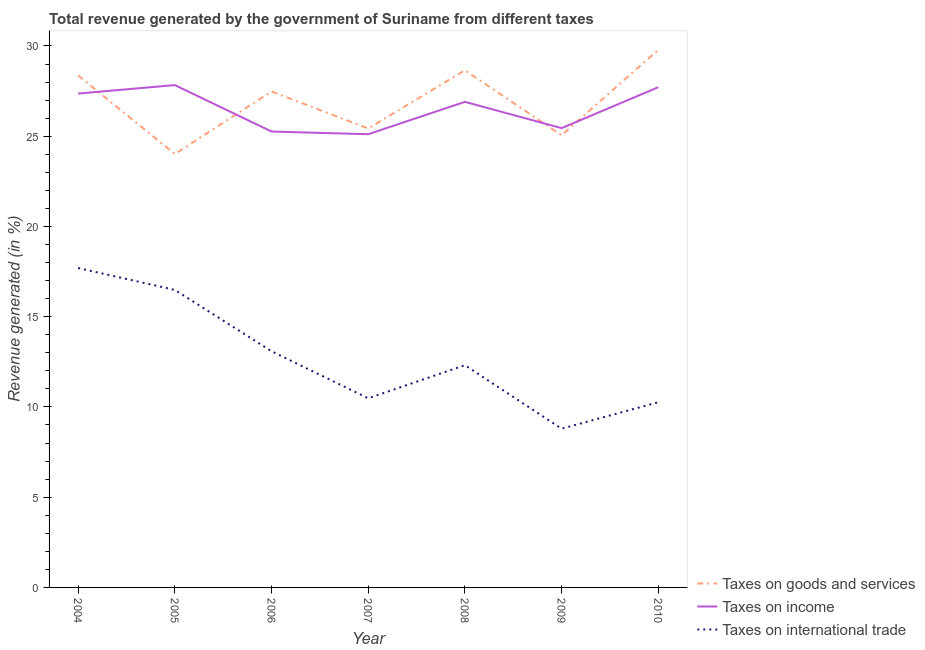Does the line corresponding to percentage of revenue generated by taxes on income intersect with the line corresponding to percentage of revenue generated by tax on international trade?
Ensure brevity in your answer.  No. What is the percentage of revenue generated by taxes on income in 2008?
Give a very brief answer. 26.9. Across all years, what is the maximum percentage of revenue generated by tax on international trade?
Make the answer very short. 17.7. Across all years, what is the minimum percentage of revenue generated by taxes on income?
Your response must be concise. 25.11. In which year was the percentage of revenue generated by tax on international trade minimum?
Offer a very short reply. 2009. What is the total percentage of revenue generated by tax on international trade in the graph?
Give a very brief answer. 89.12. What is the difference between the percentage of revenue generated by tax on international trade in 2004 and that in 2009?
Your response must be concise. 8.9. What is the difference between the percentage of revenue generated by taxes on goods and services in 2008 and the percentage of revenue generated by taxes on income in 2005?
Offer a terse response. 0.82. What is the average percentage of revenue generated by taxes on goods and services per year?
Your response must be concise. 26.97. In the year 2008, what is the difference between the percentage of revenue generated by taxes on income and percentage of revenue generated by tax on international trade?
Your response must be concise. 14.59. In how many years, is the percentage of revenue generated by tax on international trade greater than 26 %?
Provide a short and direct response. 0. What is the ratio of the percentage of revenue generated by taxes on income in 2007 to that in 2009?
Make the answer very short. 0.99. Is the percentage of revenue generated by tax on international trade in 2004 less than that in 2008?
Give a very brief answer. No. What is the difference between the highest and the second highest percentage of revenue generated by tax on international trade?
Your answer should be compact. 1.21. What is the difference between the highest and the lowest percentage of revenue generated by tax on international trade?
Your response must be concise. 8.9. In how many years, is the percentage of revenue generated by tax on international trade greater than the average percentage of revenue generated by tax on international trade taken over all years?
Provide a succinct answer. 3. Is it the case that in every year, the sum of the percentage of revenue generated by taxes on goods and services and percentage of revenue generated by taxes on income is greater than the percentage of revenue generated by tax on international trade?
Provide a succinct answer. Yes. Does the percentage of revenue generated by taxes on income monotonically increase over the years?
Offer a terse response. No. How many years are there in the graph?
Provide a short and direct response. 7. Does the graph contain any zero values?
Offer a very short reply. No. Where does the legend appear in the graph?
Give a very brief answer. Bottom right. How are the legend labels stacked?
Your answer should be very brief. Vertical. What is the title of the graph?
Offer a terse response. Total revenue generated by the government of Suriname from different taxes. What is the label or title of the X-axis?
Offer a terse response. Year. What is the label or title of the Y-axis?
Your answer should be very brief. Revenue generated (in %). What is the Revenue generated (in %) of Taxes on goods and services in 2004?
Make the answer very short. 28.37. What is the Revenue generated (in %) in Taxes on income in 2004?
Your answer should be compact. 27.36. What is the Revenue generated (in %) of Taxes on international trade in 2004?
Keep it short and to the point. 17.7. What is the Revenue generated (in %) of Taxes on goods and services in 2005?
Provide a succinct answer. 24.01. What is the Revenue generated (in %) in Taxes on income in 2005?
Give a very brief answer. 27.83. What is the Revenue generated (in %) of Taxes on international trade in 2005?
Offer a terse response. 16.48. What is the Revenue generated (in %) of Taxes on goods and services in 2006?
Provide a succinct answer. 27.48. What is the Revenue generated (in %) of Taxes on income in 2006?
Your response must be concise. 25.26. What is the Revenue generated (in %) in Taxes on international trade in 2006?
Ensure brevity in your answer.  13.09. What is the Revenue generated (in %) in Taxes on goods and services in 2007?
Your response must be concise. 25.43. What is the Revenue generated (in %) in Taxes on income in 2007?
Offer a very short reply. 25.11. What is the Revenue generated (in %) of Taxes on international trade in 2007?
Provide a short and direct response. 10.48. What is the Revenue generated (in %) in Taxes on goods and services in 2008?
Give a very brief answer. 28.65. What is the Revenue generated (in %) in Taxes on income in 2008?
Your answer should be very brief. 26.9. What is the Revenue generated (in %) in Taxes on international trade in 2008?
Keep it short and to the point. 12.31. What is the Revenue generated (in %) of Taxes on goods and services in 2009?
Your answer should be very brief. 25.05. What is the Revenue generated (in %) in Taxes on income in 2009?
Offer a terse response. 25.45. What is the Revenue generated (in %) of Taxes on international trade in 2009?
Provide a short and direct response. 8.79. What is the Revenue generated (in %) of Taxes on goods and services in 2010?
Provide a succinct answer. 29.79. What is the Revenue generated (in %) in Taxes on income in 2010?
Give a very brief answer. 27.72. What is the Revenue generated (in %) of Taxes on international trade in 2010?
Offer a terse response. 10.26. Across all years, what is the maximum Revenue generated (in %) in Taxes on goods and services?
Offer a very short reply. 29.79. Across all years, what is the maximum Revenue generated (in %) in Taxes on income?
Make the answer very short. 27.83. Across all years, what is the maximum Revenue generated (in %) of Taxes on international trade?
Keep it short and to the point. 17.7. Across all years, what is the minimum Revenue generated (in %) in Taxes on goods and services?
Make the answer very short. 24.01. Across all years, what is the minimum Revenue generated (in %) in Taxes on income?
Offer a terse response. 25.11. Across all years, what is the minimum Revenue generated (in %) of Taxes on international trade?
Your response must be concise. 8.79. What is the total Revenue generated (in %) of Taxes on goods and services in the graph?
Your answer should be compact. 188.78. What is the total Revenue generated (in %) in Taxes on income in the graph?
Offer a very short reply. 185.63. What is the total Revenue generated (in %) of Taxes on international trade in the graph?
Provide a short and direct response. 89.12. What is the difference between the Revenue generated (in %) of Taxes on goods and services in 2004 and that in 2005?
Provide a short and direct response. 4.36. What is the difference between the Revenue generated (in %) of Taxes on income in 2004 and that in 2005?
Your answer should be very brief. -0.47. What is the difference between the Revenue generated (in %) of Taxes on international trade in 2004 and that in 2005?
Provide a short and direct response. 1.21. What is the difference between the Revenue generated (in %) of Taxes on goods and services in 2004 and that in 2006?
Provide a short and direct response. 0.89. What is the difference between the Revenue generated (in %) in Taxes on income in 2004 and that in 2006?
Provide a succinct answer. 2.1. What is the difference between the Revenue generated (in %) in Taxes on international trade in 2004 and that in 2006?
Keep it short and to the point. 4.61. What is the difference between the Revenue generated (in %) in Taxes on goods and services in 2004 and that in 2007?
Your answer should be compact. 2.94. What is the difference between the Revenue generated (in %) in Taxes on income in 2004 and that in 2007?
Offer a terse response. 2.25. What is the difference between the Revenue generated (in %) of Taxes on international trade in 2004 and that in 2007?
Your answer should be compact. 7.22. What is the difference between the Revenue generated (in %) of Taxes on goods and services in 2004 and that in 2008?
Make the answer very short. -0.28. What is the difference between the Revenue generated (in %) in Taxes on income in 2004 and that in 2008?
Keep it short and to the point. 0.46. What is the difference between the Revenue generated (in %) of Taxes on international trade in 2004 and that in 2008?
Give a very brief answer. 5.38. What is the difference between the Revenue generated (in %) of Taxes on goods and services in 2004 and that in 2009?
Your response must be concise. 3.32. What is the difference between the Revenue generated (in %) of Taxes on income in 2004 and that in 2009?
Give a very brief answer. 1.92. What is the difference between the Revenue generated (in %) of Taxes on international trade in 2004 and that in 2009?
Keep it short and to the point. 8.9. What is the difference between the Revenue generated (in %) in Taxes on goods and services in 2004 and that in 2010?
Make the answer very short. -1.42. What is the difference between the Revenue generated (in %) in Taxes on income in 2004 and that in 2010?
Your response must be concise. -0.35. What is the difference between the Revenue generated (in %) of Taxes on international trade in 2004 and that in 2010?
Your answer should be very brief. 7.44. What is the difference between the Revenue generated (in %) of Taxes on goods and services in 2005 and that in 2006?
Your answer should be compact. -3.47. What is the difference between the Revenue generated (in %) in Taxes on income in 2005 and that in 2006?
Keep it short and to the point. 2.57. What is the difference between the Revenue generated (in %) of Taxes on international trade in 2005 and that in 2006?
Offer a terse response. 3.4. What is the difference between the Revenue generated (in %) of Taxes on goods and services in 2005 and that in 2007?
Provide a short and direct response. -1.42. What is the difference between the Revenue generated (in %) in Taxes on income in 2005 and that in 2007?
Offer a terse response. 2.72. What is the difference between the Revenue generated (in %) of Taxes on international trade in 2005 and that in 2007?
Make the answer very short. 6. What is the difference between the Revenue generated (in %) in Taxes on goods and services in 2005 and that in 2008?
Provide a short and direct response. -4.64. What is the difference between the Revenue generated (in %) of Taxes on income in 2005 and that in 2008?
Ensure brevity in your answer.  0.93. What is the difference between the Revenue generated (in %) in Taxes on international trade in 2005 and that in 2008?
Your answer should be very brief. 4.17. What is the difference between the Revenue generated (in %) of Taxes on goods and services in 2005 and that in 2009?
Offer a very short reply. -1.04. What is the difference between the Revenue generated (in %) in Taxes on income in 2005 and that in 2009?
Make the answer very short. 2.38. What is the difference between the Revenue generated (in %) in Taxes on international trade in 2005 and that in 2009?
Provide a succinct answer. 7.69. What is the difference between the Revenue generated (in %) of Taxes on goods and services in 2005 and that in 2010?
Ensure brevity in your answer.  -5.78. What is the difference between the Revenue generated (in %) in Taxes on income in 2005 and that in 2010?
Make the answer very short. 0.12. What is the difference between the Revenue generated (in %) of Taxes on international trade in 2005 and that in 2010?
Keep it short and to the point. 6.22. What is the difference between the Revenue generated (in %) in Taxes on goods and services in 2006 and that in 2007?
Offer a terse response. 2.05. What is the difference between the Revenue generated (in %) of Taxes on income in 2006 and that in 2007?
Provide a succinct answer. 0.15. What is the difference between the Revenue generated (in %) of Taxes on international trade in 2006 and that in 2007?
Your response must be concise. 2.61. What is the difference between the Revenue generated (in %) of Taxes on goods and services in 2006 and that in 2008?
Keep it short and to the point. -1.17. What is the difference between the Revenue generated (in %) of Taxes on income in 2006 and that in 2008?
Offer a very short reply. -1.64. What is the difference between the Revenue generated (in %) in Taxes on international trade in 2006 and that in 2008?
Keep it short and to the point. 0.77. What is the difference between the Revenue generated (in %) in Taxes on goods and services in 2006 and that in 2009?
Provide a succinct answer. 2.43. What is the difference between the Revenue generated (in %) of Taxes on income in 2006 and that in 2009?
Provide a succinct answer. -0.19. What is the difference between the Revenue generated (in %) of Taxes on international trade in 2006 and that in 2009?
Offer a very short reply. 4.29. What is the difference between the Revenue generated (in %) of Taxes on goods and services in 2006 and that in 2010?
Make the answer very short. -2.31. What is the difference between the Revenue generated (in %) in Taxes on income in 2006 and that in 2010?
Your answer should be very brief. -2.46. What is the difference between the Revenue generated (in %) in Taxes on international trade in 2006 and that in 2010?
Ensure brevity in your answer.  2.83. What is the difference between the Revenue generated (in %) in Taxes on goods and services in 2007 and that in 2008?
Ensure brevity in your answer.  -3.22. What is the difference between the Revenue generated (in %) in Taxes on income in 2007 and that in 2008?
Ensure brevity in your answer.  -1.79. What is the difference between the Revenue generated (in %) of Taxes on international trade in 2007 and that in 2008?
Offer a very short reply. -1.83. What is the difference between the Revenue generated (in %) in Taxes on goods and services in 2007 and that in 2009?
Give a very brief answer. 0.38. What is the difference between the Revenue generated (in %) in Taxes on income in 2007 and that in 2009?
Provide a succinct answer. -0.34. What is the difference between the Revenue generated (in %) in Taxes on international trade in 2007 and that in 2009?
Ensure brevity in your answer.  1.69. What is the difference between the Revenue generated (in %) in Taxes on goods and services in 2007 and that in 2010?
Offer a very short reply. -4.36. What is the difference between the Revenue generated (in %) of Taxes on income in 2007 and that in 2010?
Provide a short and direct response. -2.6. What is the difference between the Revenue generated (in %) in Taxes on international trade in 2007 and that in 2010?
Offer a terse response. 0.22. What is the difference between the Revenue generated (in %) in Taxes on goods and services in 2008 and that in 2009?
Your response must be concise. 3.6. What is the difference between the Revenue generated (in %) of Taxes on income in 2008 and that in 2009?
Ensure brevity in your answer.  1.46. What is the difference between the Revenue generated (in %) of Taxes on international trade in 2008 and that in 2009?
Provide a succinct answer. 3.52. What is the difference between the Revenue generated (in %) of Taxes on goods and services in 2008 and that in 2010?
Keep it short and to the point. -1.14. What is the difference between the Revenue generated (in %) in Taxes on income in 2008 and that in 2010?
Your answer should be compact. -0.81. What is the difference between the Revenue generated (in %) of Taxes on international trade in 2008 and that in 2010?
Your response must be concise. 2.05. What is the difference between the Revenue generated (in %) in Taxes on goods and services in 2009 and that in 2010?
Make the answer very short. -4.74. What is the difference between the Revenue generated (in %) in Taxes on income in 2009 and that in 2010?
Offer a terse response. -2.27. What is the difference between the Revenue generated (in %) in Taxes on international trade in 2009 and that in 2010?
Ensure brevity in your answer.  -1.47. What is the difference between the Revenue generated (in %) of Taxes on goods and services in 2004 and the Revenue generated (in %) of Taxes on income in 2005?
Make the answer very short. 0.54. What is the difference between the Revenue generated (in %) of Taxes on goods and services in 2004 and the Revenue generated (in %) of Taxes on international trade in 2005?
Make the answer very short. 11.88. What is the difference between the Revenue generated (in %) in Taxes on income in 2004 and the Revenue generated (in %) in Taxes on international trade in 2005?
Provide a succinct answer. 10.88. What is the difference between the Revenue generated (in %) in Taxes on goods and services in 2004 and the Revenue generated (in %) in Taxes on income in 2006?
Your answer should be very brief. 3.11. What is the difference between the Revenue generated (in %) in Taxes on goods and services in 2004 and the Revenue generated (in %) in Taxes on international trade in 2006?
Make the answer very short. 15.28. What is the difference between the Revenue generated (in %) of Taxes on income in 2004 and the Revenue generated (in %) of Taxes on international trade in 2006?
Your answer should be very brief. 14.28. What is the difference between the Revenue generated (in %) in Taxes on goods and services in 2004 and the Revenue generated (in %) in Taxes on income in 2007?
Keep it short and to the point. 3.26. What is the difference between the Revenue generated (in %) of Taxes on goods and services in 2004 and the Revenue generated (in %) of Taxes on international trade in 2007?
Your answer should be very brief. 17.89. What is the difference between the Revenue generated (in %) of Taxes on income in 2004 and the Revenue generated (in %) of Taxes on international trade in 2007?
Offer a terse response. 16.88. What is the difference between the Revenue generated (in %) of Taxes on goods and services in 2004 and the Revenue generated (in %) of Taxes on income in 2008?
Provide a short and direct response. 1.46. What is the difference between the Revenue generated (in %) of Taxes on goods and services in 2004 and the Revenue generated (in %) of Taxes on international trade in 2008?
Offer a terse response. 16.05. What is the difference between the Revenue generated (in %) in Taxes on income in 2004 and the Revenue generated (in %) in Taxes on international trade in 2008?
Give a very brief answer. 15.05. What is the difference between the Revenue generated (in %) in Taxes on goods and services in 2004 and the Revenue generated (in %) in Taxes on income in 2009?
Ensure brevity in your answer.  2.92. What is the difference between the Revenue generated (in %) in Taxes on goods and services in 2004 and the Revenue generated (in %) in Taxes on international trade in 2009?
Your response must be concise. 19.57. What is the difference between the Revenue generated (in %) in Taxes on income in 2004 and the Revenue generated (in %) in Taxes on international trade in 2009?
Keep it short and to the point. 18.57. What is the difference between the Revenue generated (in %) in Taxes on goods and services in 2004 and the Revenue generated (in %) in Taxes on income in 2010?
Give a very brief answer. 0.65. What is the difference between the Revenue generated (in %) in Taxes on goods and services in 2004 and the Revenue generated (in %) in Taxes on international trade in 2010?
Provide a short and direct response. 18.11. What is the difference between the Revenue generated (in %) in Taxes on income in 2004 and the Revenue generated (in %) in Taxes on international trade in 2010?
Your answer should be very brief. 17.1. What is the difference between the Revenue generated (in %) of Taxes on goods and services in 2005 and the Revenue generated (in %) of Taxes on income in 2006?
Your answer should be very brief. -1.25. What is the difference between the Revenue generated (in %) in Taxes on goods and services in 2005 and the Revenue generated (in %) in Taxes on international trade in 2006?
Provide a succinct answer. 10.93. What is the difference between the Revenue generated (in %) in Taxes on income in 2005 and the Revenue generated (in %) in Taxes on international trade in 2006?
Ensure brevity in your answer.  14.75. What is the difference between the Revenue generated (in %) in Taxes on goods and services in 2005 and the Revenue generated (in %) in Taxes on income in 2007?
Offer a very short reply. -1.1. What is the difference between the Revenue generated (in %) in Taxes on goods and services in 2005 and the Revenue generated (in %) in Taxes on international trade in 2007?
Give a very brief answer. 13.53. What is the difference between the Revenue generated (in %) in Taxes on income in 2005 and the Revenue generated (in %) in Taxes on international trade in 2007?
Keep it short and to the point. 17.35. What is the difference between the Revenue generated (in %) of Taxes on goods and services in 2005 and the Revenue generated (in %) of Taxes on income in 2008?
Give a very brief answer. -2.89. What is the difference between the Revenue generated (in %) in Taxes on goods and services in 2005 and the Revenue generated (in %) in Taxes on international trade in 2008?
Your response must be concise. 11.7. What is the difference between the Revenue generated (in %) of Taxes on income in 2005 and the Revenue generated (in %) of Taxes on international trade in 2008?
Make the answer very short. 15.52. What is the difference between the Revenue generated (in %) in Taxes on goods and services in 2005 and the Revenue generated (in %) in Taxes on income in 2009?
Ensure brevity in your answer.  -1.44. What is the difference between the Revenue generated (in %) in Taxes on goods and services in 2005 and the Revenue generated (in %) in Taxes on international trade in 2009?
Provide a short and direct response. 15.22. What is the difference between the Revenue generated (in %) in Taxes on income in 2005 and the Revenue generated (in %) in Taxes on international trade in 2009?
Keep it short and to the point. 19.04. What is the difference between the Revenue generated (in %) in Taxes on goods and services in 2005 and the Revenue generated (in %) in Taxes on income in 2010?
Offer a very short reply. -3.7. What is the difference between the Revenue generated (in %) in Taxes on goods and services in 2005 and the Revenue generated (in %) in Taxes on international trade in 2010?
Give a very brief answer. 13.75. What is the difference between the Revenue generated (in %) of Taxes on income in 2005 and the Revenue generated (in %) of Taxes on international trade in 2010?
Offer a very short reply. 17.57. What is the difference between the Revenue generated (in %) in Taxes on goods and services in 2006 and the Revenue generated (in %) in Taxes on income in 2007?
Provide a short and direct response. 2.37. What is the difference between the Revenue generated (in %) of Taxes on goods and services in 2006 and the Revenue generated (in %) of Taxes on international trade in 2007?
Keep it short and to the point. 17. What is the difference between the Revenue generated (in %) in Taxes on income in 2006 and the Revenue generated (in %) in Taxes on international trade in 2007?
Make the answer very short. 14.78. What is the difference between the Revenue generated (in %) in Taxes on goods and services in 2006 and the Revenue generated (in %) in Taxes on income in 2008?
Provide a short and direct response. 0.58. What is the difference between the Revenue generated (in %) in Taxes on goods and services in 2006 and the Revenue generated (in %) in Taxes on international trade in 2008?
Your answer should be very brief. 15.17. What is the difference between the Revenue generated (in %) of Taxes on income in 2006 and the Revenue generated (in %) of Taxes on international trade in 2008?
Make the answer very short. 12.95. What is the difference between the Revenue generated (in %) in Taxes on goods and services in 2006 and the Revenue generated (in %) in Taxes on income in 2009?
Offer a very short reply. 2.03. What is the difference between the Revenue generated (in %) in Taxes on goods and services in 2006 and the Revenue generated (in %) in Taxes on international trade in 2009?
Your response must be concise. 18.69. What is the difference between the Revenue generated (in %) in Taxes on income in 2006 and the Revenue generated (in %) in Taxes on international trade in 2009?
Give a very brief answer. 16.46. What is the difference between the Revenue generated (in %) of Taxes on goods and services in 2006 and the Revenue generated (in %) of Taxes on income in 2010?
Provide a succinct answer. -0.24. What is the difference between the Revenue generated (in %) of Taxes on goods and services in 2006 and the Revenue generated (in %) of Taxes on international trade in 2010?
Your response must be concise. 17.22. What is the difference between the Revenue generated (in %) of Taxes on income in 2006 and the Revenue generated (in %) of Taxes on international trade in 2010?
Provide a succinct answer. 15. What is the difference between the Revenue generated (in %) in Taxes on goods and services in 2007 and the Revenue generated (in %) in Taxes on income in 2008?
Your answer should be compact. -1.48. What is the difference between the Revenue generated (in %) in Taxes on goods and services in 2007 and the Revenue generated (in %) in Taxes on international trade in 2008?
Provide a short and direct response. 13.11. What is the difference between the Revenue generated (in %) of Taxes on income in 2007 and the Revenue generated (in %) of Taxes on international trade in 2008?
Your response must be concise. 12.8. What is the difference between the Revenue generated (in %) of Taxes on goods and services in 2007 and the Revenue generated (in %) of Taxes on income in 2009?
Offer a terse response. -0.02. What is the difference between the Revenue generated (in %) in Taxes on goods and services in 2007 and the Revenue generated (in %) in Taxes on international trade in 2009?
Provide a short and direct response. 16.63. What is the difference between the Revenue generated (in %) of Taxes on income in 2007 and the Revenue generated (in %) of Taxes on international trade in 2009?
Give a very brief answer. 16.32. What is the difference between the Revenue generated (in %) in Taxes on goods and services in 2007 and the Revenue generated (in %) in Taxes on income in 2010?
Your answer should be very brief. -2.29. What is the difference between the Revenue generated (in %) in Taxes on goods and services in 2007 and the Revenue generated (in %) in Taxes on international trade in 2010?
Your response must be concise. 15.17. What is the difference between the Revenue generated (in %) in Taxes on income in 2007 and the Revenue generated (in %) in Taxes on international trade in 2010?
Provide a succinct answer. 14.85. What is the difference between the Revenue generated (in %) of Taxes on goods and services in 2008 and the Revenue generated (in %) of Taxes on income in 2009?
Your answer should be compact. 3.2. What is the difference between the Revenue generated (in %) of Taxes on goods and services in 2008 and the Revenue generated (in %) of Taxes on international trade in 2009?
Provide a short and direct response. 19.86. What is the difference between the Revenue generated (in %) of Taxes on income in 2008 and the Revenue generated (in %) of Taxes on international trade in 2009?
Make the answer very short. 18.11. What is the difference between the Revenue generated (in %) of Taxes on goods and services in 2008 and the Revenue generated (in %) of Taxes on income in 2010?
Your answer should be compact. 0.94. What is the difference between the Revenue generated (in %) in Taxes on goods and services in 2008 and the Revenue generated (in %) in Taxes on international trade in 2010?
Ensure brevity in your answer.  18.39. What is the difference between the Revenue generated (in %) in Taxes on income in 2008 and the Revenue generated (in %) in Taxes on international trade in 2010?
Offer a terse response. 16.64. What is the difference between the Revenue generated (in %) in Taxes on goods and services in 2009 and the Revenue generated (in %) in Taxes on income in 2010?
Offer a terse response. -2.66. What is the difference between the Revenue generated (in %) in Taxes on goods and services in 2009 and the Revenue generated (in %) in Taxes on international trade in 2010?
Offer a very short reply. 14.79. What is the difference between the Revenue generated (in %) in Taxes on income in 2009 and the Revenue generated (in %) in Taxes on international trade in 2010?
Provide a short and direct response. 15.19. What is the average Revenue generated (in %) of Taxes on goods and services per year?
Your answer should be compact. 26.97. What is the average Revenue generated (in %) of Taxes on income per year?
Give a very brief answer. 26.52. What is the average Revenue generated (in %) of Taxes on international trade per year?
Provide a short and direct response. 12.73. In the year 2004, what is the difference between the Revenue generated (in %) in Taxes on goods and services and Revenue generated (in %) in Taxes on income?
Provide a succinct answer. 1.01. In the year 2004, what is the difference between the Revenue generated (in %) in Taxes on goods and services and Revenue generated (in %) in Taxes on international trade?
Keep it short and to the point. 10.67. In the year 2004, what is the difference between the Revenue generated (in %) of Taxes on income and Revenue generated (in %) of Taxes on international trade?
Make the answer very short. 9.67. In the year 2005, what is the difference between the Revenue generated (in %) in Taxes on goods and services and Revenue generated (in %) in Taxes on income?
Your answer should be compact. -3.82. In the year 2005, what is the difference between the Revenue generated (in %) in Taxes on goods and services and Revenue generated (in %) in Taxes on international trade?
Your answer should be compact. 7.53. In the year 2005, what is the difference between the Revenue generated (in %) in Taxes on income and Revenue generated (in %) in Taxes on international trade?
Provide a short and direct response. 11.35. In the year 2006, what is the difference between the Revenue generated (in %) in Taxes on goods and services and Revenue generated (in %) in Taxes on income?
Your answer should be compact. 2.22. In the year 2006, what is the difference between the Revenue generated (in %) of Taxes on goods and services and Revenue generated (in %) of Taxes on international trade?
Offer a terse response. 14.39. In the year 2006, what is the difference between the Revenue generated (in %) of Taxes on income and Revenue generated (in %) of Taxes on international trade?
Provide a short and direct response. 12.17. In the year 2007, what is the difference between the Revenue generated (in %) of Taxes on goods and services and Revenue generated (in %) of Taxes on income?
Give a very brief answer. 0.32. In the year 2007, what is the difference between the Revenue generated (in %) in Taxes on goods and services and Revenue generated (in %) in Taxes on international trade?
Make the answer very short. 14.95. In the year 2007, what is the difference between the Revenue generated (in %) in Taxes on income and Revenue generated (in %) in Taxes on international trade?
Provide a succinct answer. 14.63. In the year 2008, what is the difference between the Revenue generated (in %) in Taxes on goods and services and Revenue generated (in %) in Taxes on income?
Provide a short and direct response. 1.75. In the year 2008, what is the difference between the Revenue generated (in %) in Taxes on goods and services and Revenue generated (in %) in Taxes on international trade?
Ensure brevity in your answer.  16.34. In the year 2008, what is the difference between the Revenue generated (in %) in Taxes on income and Revenue generated (in %) in Taxes on international trade?
Keep it short and to the point. 14.59. In the year 2009, what is the difference between the Revenue generated (in %) in Taxes on goods and services and Revenue generated (in %) in Taxes on income?
Keep it short and to the point. -0.4. In the year 2009, what is the difference between the Revenue generated (in %) of Taxes on goods and services and Revenue generated (in %) of Taxes on international trade?
Ensure brevity in your answer.  16.26. In the year 2009, what is the difference between the Revenue generated (in %) of Taxes on income and Revenue generated (in %) of Taxes on international trade?
Make the answer very short. 16.65. In the year 2010, what is the difference between the Revenue generated (in %) in Taxes on goods and services and Revenue generated (in %) in Taxes on income?
Your response must be concise. 2.07. In the year 2010, what is the difference between the Revenue generated (in %) in Taxes on goods and services and Revenue generated (in %) in Taxes on international trade?
Make the answer very short. 19.53. In the year 2010, what is the difference between the Revenue generated (in %) in Taxes on income and Revenue generated (in %) in Taxes on international trade?
Offer a very short reply. 17.46. What is the ratio of the Revenue generated (in %) in Taxes on goods and services in 2004 to that in 2005?
Make the answer very short. 1.18. What is the ratio of the Revenue generated (in %) of Taxes on income in 2004 to that in 2005?
Offer a very short reply. 0.98. What is the ratio of the Revenue generated (in %) in Taxes on international trade in 2004 to that in 2005?
Your answer should be very brief. 1.07. What is the ratio of the Revenue generated (in %) of Taxes on goods and services in 2004 to that in 2006?
Ensure brevity in your answer.  1.03. What is the ratio of the Revenue generated (in %) of Taxes on income in 2004 to that in 2006?
Your answer should be very brief. 1.08. What is the ratio of the Revenue generated (in %) in Taxes on international trade in 2004 to that in 2006?
Give a very brief answer. 1.35. What is the ratio of the Revenue generated (in %) in Taxes on goods and services in 2004 to that in 2007?
Keep it short and to the point. 1.12. What is the ratio of the Revenue generated (in %) of Taxes on income in 2004 to that in 2007?
Provide a succinct answer. 1.09. What is the ratio of the Revenue generated (in %) of Taxes on international trade in 2004 to that in 2007?
Provide a short and direct response. 1.69. What is the ratio of the Revenue generated (in %) of Taxes on goods and services in 2004 to that in 2008?
Ensure brevity in your answer.  0.99. What is the ratio of the Revenue generated (in %) of Taxes on income in 2004 to that in 2008?
Your response must be concise. 1.02. What is the ratio of the Revenue generated (in %) of Taxes on international trade in 2004 to that in 2008?
Ensure brevity in your answer.  1.44. What is the ratio of the Revenue generated (in %) in Taxes on goods and services in 2004 to that in 2009?
Your answer should be compact. 1.13. What is the ratio of the Revenue generated (in %) in Taxes on income in 2004 to that in 2009?
Make the answer very short. 1.08. What is the ratio of the Revenue generated (in %) in Taxes on international trade in 2004 to that in 2009?
Your answer should be very brief. 2.01. What is the ratio of the Revenue generated (in %) in Taxes on goods and services in 2004 to that in 2010?
Provide a succinct answer. 0.95. What is the ratio of the Revenue generated (in %) in Taxes on income in 2004 to that in 2010?
Keep it short and to the point. 0.99. What is the ratio of the Revenue generated (in %) in Taxes on international trade in 2004 to that in 2010?
Ensure brevity in your answer.  1.72. What is the ratio of the Revenue generated (in %) in Taxes on goods and services in 2005 to that in 2006?
Your response must be concise. 0.87. What is the ratio of the Revenue generated (in %) in Taxes on income in 2005 to that in 2006?
Give a very brief answer. 1.1. What is the ratio of the Revenue generated (in %) of Taxes on international trade in 2005 to that in 2006?
Offer a terse response. 1.26. What is the ratio of the Revenue generated (in %) of Taxes on goods and services in 2005 to that in 2007?
Offer a terse response. 0.94. What is the ratio of the Revenue generated (in %) of Taxes on income in 2005 to that in 2007?
Offer a terse response. 1.11. What is the ratio of the Revenue generated (in %) of Taxes on international trade in 2005 to that in 2007?
Make the answer very short. 1.57. What is the ratio of the Revenue generated (in %) in Taxes on goods and services in 2005 to that in 2008?
Ensure brevity in your answer.  0.84. What is the ratio of the Revenue generated (in %) of Taxes on income in 2005 to that in 2008?
Your response must be concise. 1.03. What is the ratio of the Revenue generated (in %) of Taxes on international trade in 2005 to that in 2008?
Offer a terse response. 1.34. What is the ratio of the Revenue generated (in %) in Taxes on goods and services in 2005 to that in 2009?
Make the answer very short. 0.96. What is the ratio of the Revenue generated (in %) of Taxes on income in 2005 to that in 2009?
Offer a terse response. 1.09. What is the ratio of the Revenue generated (in %) of Taxes on international trade in 2005 to that in 2009?
Offer a very short reply. 1.87. What is the ratio of the Revenue generated (in %) in Taxes on goods and services in 2005 to that in 2010?
Make the answer very short. 0.81. What is the ratio of the Revenue generated (in %) in Taxes on income in 2005 to that in 2010?
Offer a very short reply. 1. What is the ratio of the Revenue generated (in %) of Taxes on international trade in 2005 to that in 2010?
Provide a succinct answer. 1.61. What is the ratio of the Revenue generated (in %) in Taxes on goods and services in 2006 to that in 2007?
Offer a terse response. 1.08. What is the ratio of the Revenue generated (in %) in Taxes on income in 2006 to that in 2007?
Make the answer very short. 1.01. What is the ratio of the Revenue generated (in %) in Taxes on international trade in 2006 to that in 2007?
Your answer should be very brief. 1.25. What is the ratio of the Revenue generated (in %) in Taxes on goods and services in 2006 to that in 2008?
Offer a terse response. 0.96. What is the ratio of the Revenue generated (in %) in Taxes on income in 2006 to that in 2008?
Your answer should be very brief. 0.94. What is the ratio of the Revenue generated (in %) in Taxes on international trade in 2006 to that in 2008?
Offer a terse response. 1.06. What is the ratio of the Revenue generated (in %) in Taxes on goods and services in 2006 to that in 2009?
Offer a very short reply. 1.1. What is the ratio of the Revenue generated (in %) in Taxes on international trade in 2006 to that in 2009?
Provide a succinct answer. 1.49. What is the ratio of the Revenue generated (in %) of Taxes on goods and services in 2006 to that in 2010?
Your answer should be compact. 0.92. What is the ratio of the Revenue generated (in %) of Taxes on income in 2006 to that in 2010?
Offer a very short reply. 0.91. What is the ratio of the Revenue generated (in %) in Taxes on international trade in 2006 to that in 2010?
Your answer should be very brief. 1.28. What is the ratio of the Revenue generated (in %) of Taxes on goods and services in 2007 to that in 2008?
Your response must be concise. 0.89. What is the ratio of the Revenue generated (in %) in Taxes on income in 2007 to that in 2008?
Offer a terse response. 0.93. What is the ratio of the Revenue generated (in %) of Taxes on international trade in 2007 to that in 2008?
Offer a terse response. 0.85. What is the ratio of the Revenue generated (in %) of Taxes on international trade in 2007 to that in 2009?
Your answer should be compact. 1.19. What is the ratio of the Revenue generated (in %) of Taxes on goods and services in 2007 to that in 2010?
Provide a succinct answer. 0.85. What is the ratio of the Revenue generated (in %) in Taxes on income in 2007 to that in 2010?
Give a very brief answer. 0.91. What is the ratio of the Revenue generated (in %) in Taxes on international trade in 2007 to that in 2010?
Offer a very short reply. 1.02. What is the ratio of the Revenue generated (in %) of Taxes on goods and services in 2008 to that in 2009?
Offer a terse response. 1.14. What is the ratio of the Revenue generated (in %) in Taxes on income in 2008 to that in 2009?
Your response must be concise. 1.06. What is the ratio of the Revenue generated (in %) of Taxes on international trade in 2008 to that in 2009?
Your answer should be very brief. 1.4. What is the ratio of the Revenue generated (in %) of Taxes on goods and services in 2008 to that in 2010?
Provide a succinct answer. 0.96. What is the ratio of the Revenue generated (in %) in Taxes on income in 2008 to that in 2010?
Offer a very short reply. 0.97. What is the ratio of the Revenue generated (in %) of Taxes on international trade in 2008 to that in 2010?
Keep it short and to the point. 1.2. What is the ratio of the Revenue generated (in %) of Taxes on goods and services in 2009 to that in 2010?
Offer a very short reply. 0.84. What is the ratio of the Revenue generated (in %) in Taxes on income in 2009 to that in 2010?
Provide a succinct answer. 0.92. What is the ratio of the Revenue generated (in %) of Taxes on international trade in 2009 to that in 2010?
Your response must be concise. 0.86. What is the difference between the highest and the second highest Revenue generated (in %) in Taxes on goods and services?
Ensure brevity in your answer.  1.14. What is the difference between the highest and the second highest Revenue generated (in %) in Taxes on income?
Keep it short and to the point. 0.12. What is the difference between the highest and the second highest Revenue generated (in %) in Taxes on international trade?
Provide a short and direct response. 1.21. What is the difference between the highest and the lowest Revenue generated (in %) in Taxes on goods and services?
Your response must be concise. 5.78. What is the difference between the highest and the lowest Revenue generated (in %) of Taxes on income?
Make the answer very short. 2.72. What is the difference between the highest and the lowest Revenue generated (in %) of Taxes on international trade?
Your answer should be very brief. 8.9. 